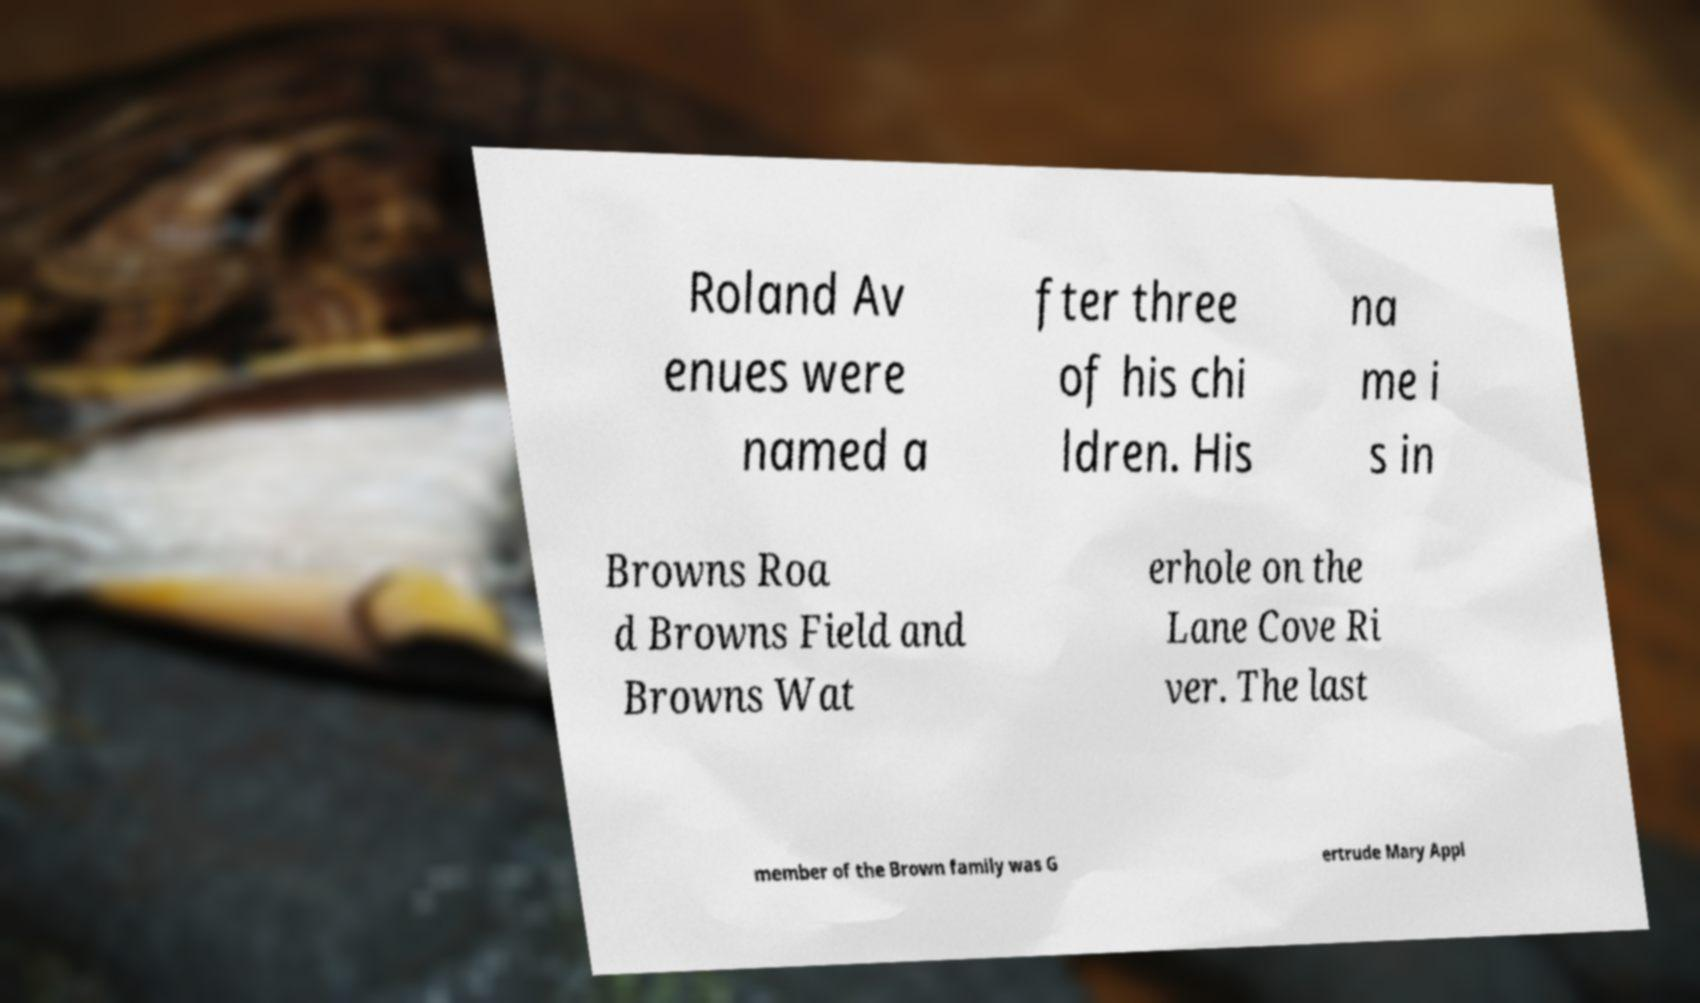I need the written content from this picture converted into text. Can you do that? Roland Av enues were named a fter three of his chi ldren. His na me i s in Browns Roa d Browns Field and Browns Wat erhole on the Lane Cove Ri ver. The last member of the Brown family was G ertrude Mary Appl 